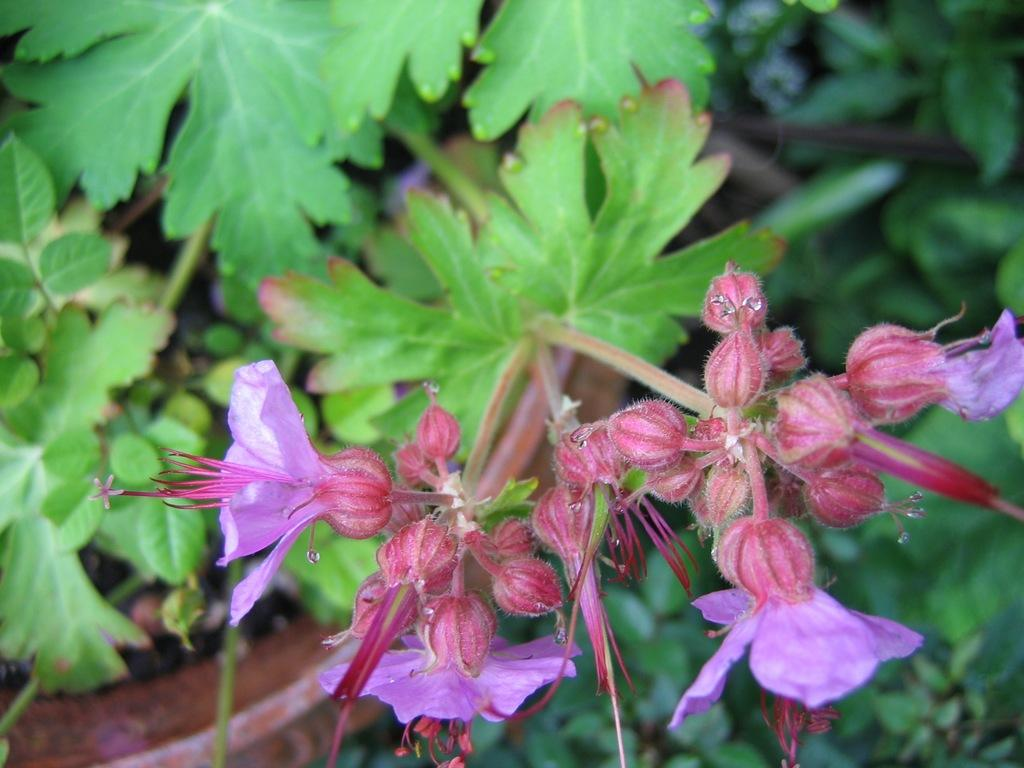What is located in the middle of the image? There are plants and flowers in the middle of the image. Can you describe the plants in the image? The plants in the image have flowers. How many sons are visible in the image? There are no sons present in the image; it features plants and flowers. What type of pig can be seen interacting with the plants in the image? There is no pig present in the image; it only features plants and flowers. 